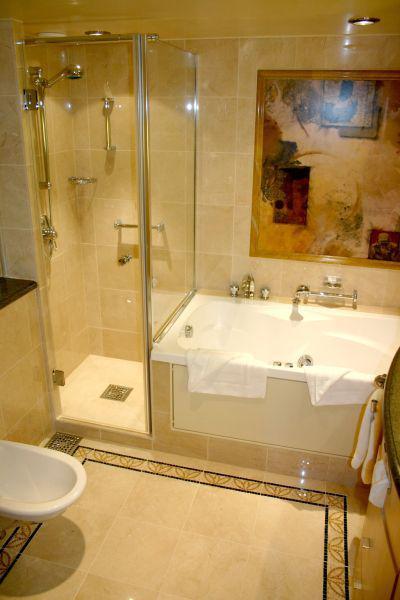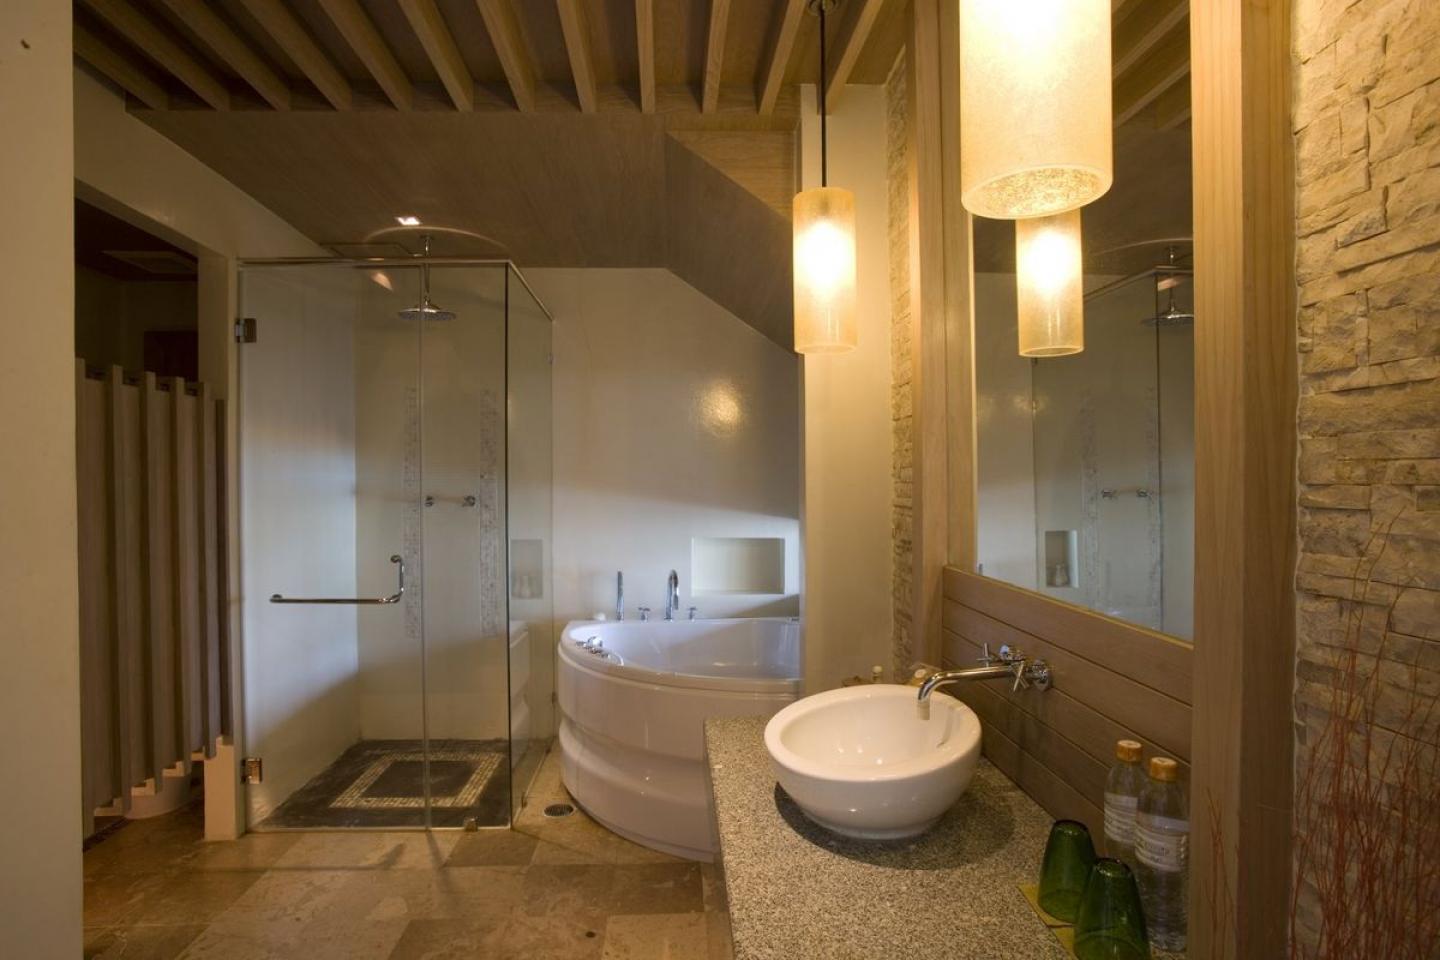The first image is the image on the left, the second image is the image on the right. Given the left and right images, does the statement "Three or more sinks are visible." hold true? Answer yes or no. No. 